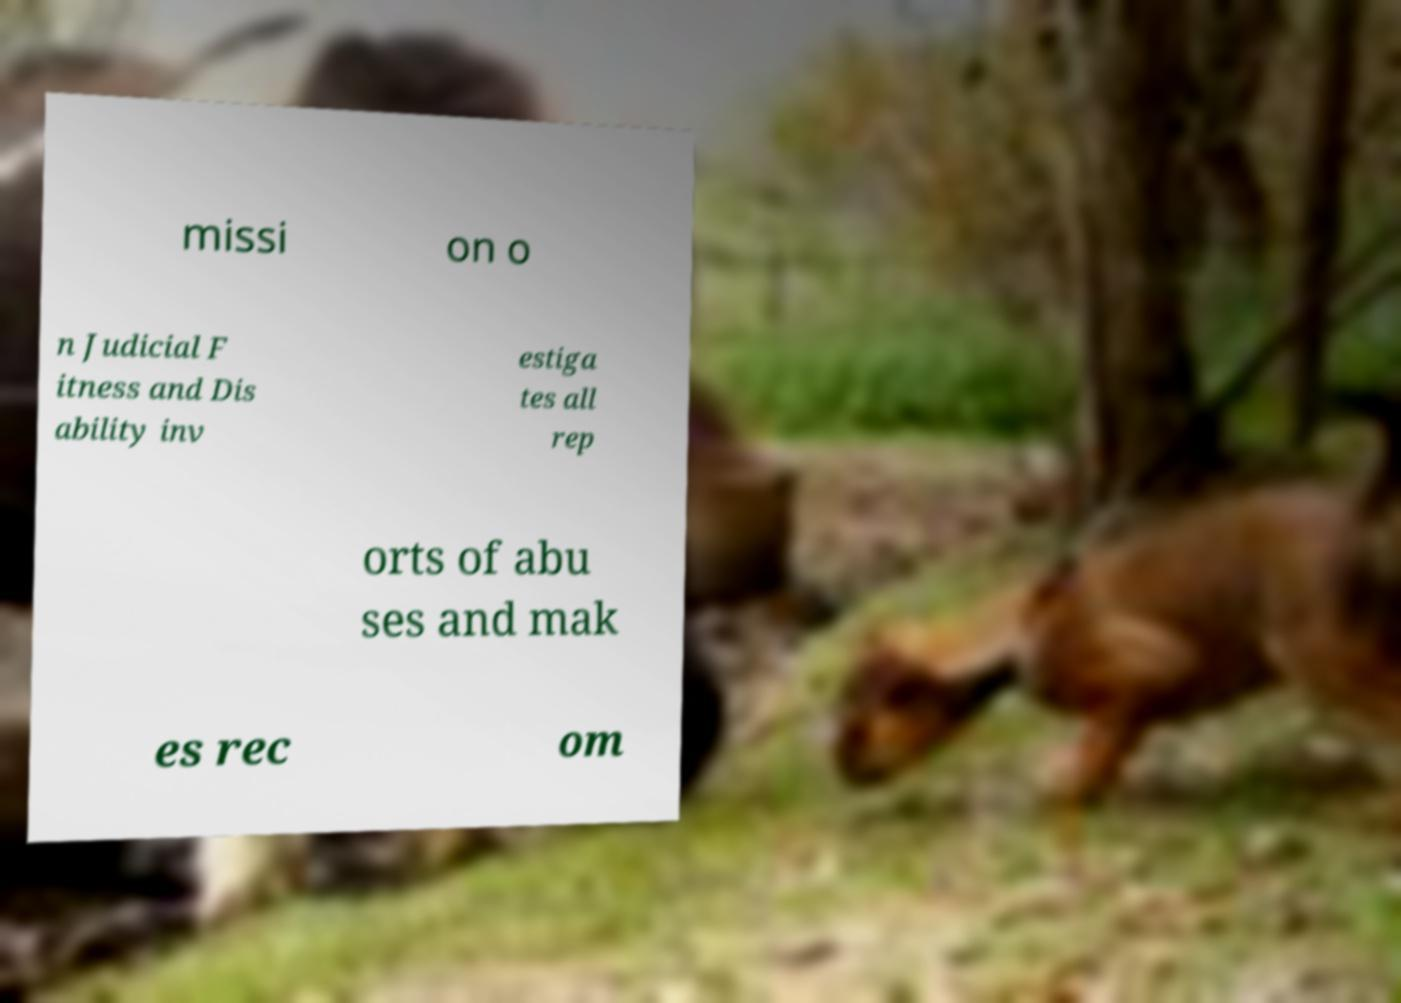Please identify and transcribe the text found in this image. missi on o n Judicial F itness and Dis ability inv estiga tes all rep orts of abu ses and mak es rec om 